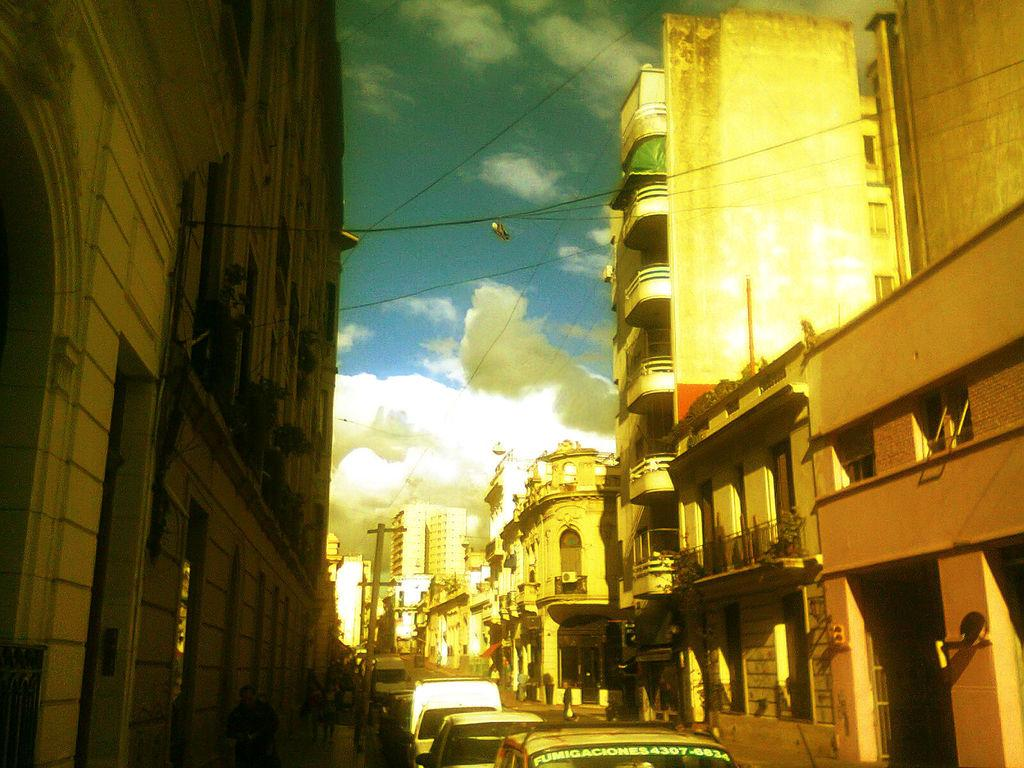What type of structures can be seen in the image? There are buildings in the image. What else is visible at the bottom of the image? There are vehicles at the bottom of the image. What can be seen in the sky in the image? There are clouds in the sky. How many ghosts can be seen interacting with the vehicles in the image? There are no ghosts present in the image; it only features buildings, vehicles, and clouds. What type of iron is being used to support the buildings in the image? There is no mention of iron being used to support the buildings in the image. 